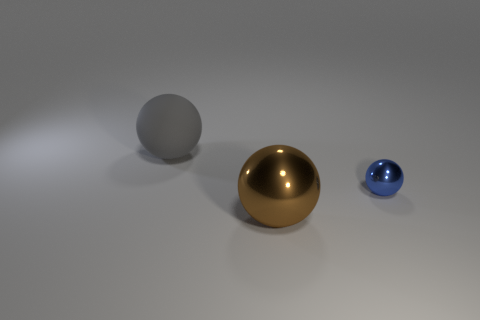What is the color of the other metal object that is the same shape as the brown object?
Ensure brevity in your answer.  Blue. Are the large gray ball and the ball that is to the right of the large brown ball made of the same material?
Your response must be concise. No. There is a thing that is to the right of the brown metal sphere; does it have the same size as the gray matte thing?
Offer a very short reply. No. How many big objects are on the left side of the large shiny object?
Give a very brief answer. 1. What number of other objects are there of the same size as the brown ball?
Ensure brevity in your answer.  1. Is the material of the sphere that is right of the brown sphere the same as the big thing in front of the blue shiny sphere?
Provide a succinct answer. Yes. There is another thing that is the same size as the gray rubber object; what color is it?
Provide a short and direct response. Brown. Is there any other thing that is the same color as the large metallic object?
Provide a succinct answer. No. How big is the metal ball that is left of the shiny sphere that is behind the big thing that is in front of the gray rubber object?
Keep it short and to the point. Large. There is a object that is left of the blue shiny object and behind the big metal sphere; what is its color?
Give a very brief answer. Gray. 